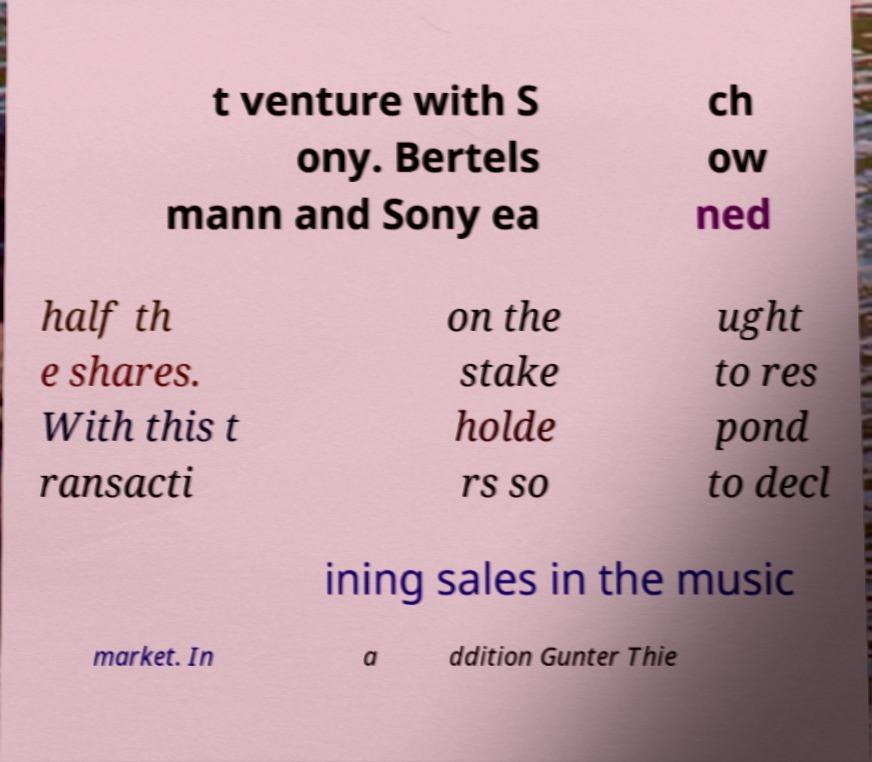Please identify and transcribe the text found in this image. t venture with S ony. Bertels mann and Sony ea ch ow ned half th e shares. With this t ransacti on the stake holde rs so ught to res pond to decl ining sales in the music market. In a ddition Gunter Thie 